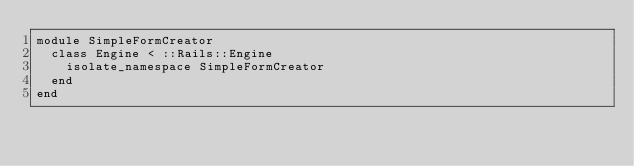Convert code to text. <code><loc_0><loc_0><loc_500><loc_500><_Ruby_>module SimpleFormCreator
  class Engine < ::Rails::Engine
    isolate_namespace SimpleFormCreator
  end
end
</code> 